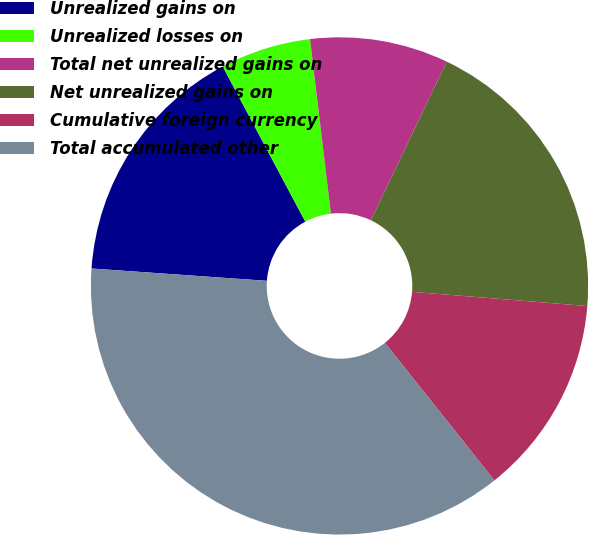<chart> <loc_0><loc_0><loc_500><loc_500><pie_chart><fcel>Unrealized gains on<fcel>Unrealized losses on<fcel>Total net unrealized gains on<fcel>Net unrealized gains on<fcel>Cumulative foreign currency<fcel>Total accumulated other<nl><fcel>16.1%<fcel>5.89%<fcel>8.99%<fcel>19.19%<fcel>13.01%<fcel>36.82%<nl></chart> 